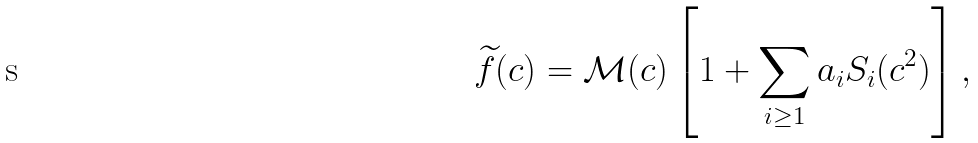Convert formula to latex. <formula><loc_0><loc_0><loc_500><loc_500>\widetilde { f } ( c ) = \mathcal { M } ( c ) \left [ 1 + \sum _ { i \geq 1 } a _ { i } S _ { i } ( c ^ { 2 } ) \right ] ,</formula> 